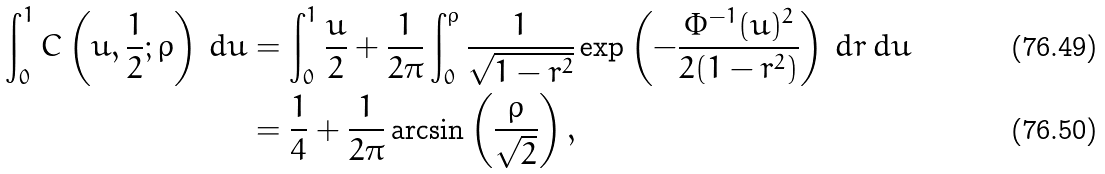<formula> <loc_0><loc_0><loc_500><loc_500>\int _ { 0 } ^ { 1 } C \left ( u , \frac { 1 } { 2 } ; \varrho \right ) \, d u & = \int _ { 0 } ^ { 1 } \frac { u } { 2 } + \frac { 1 } { 2 \pi } \int _ { 0 } ^ { \varrho } \frac { 1 } { \sqrt { 1 - r ^ { 2 } } } \exp \left ( - \frac { \Phi ^ { - 1 } ( u ) ^ { 2 } } { 2 ( 1 - r ^ { 2 } ) } \right ) \, d r \, d u \\ & = \frac { 1 } { 4 } + \frac { 1 } { 2 \pi } \arcsin \left ( \frac { \varrho } { \sqrt { 2 } } \right ) ,</formula> 